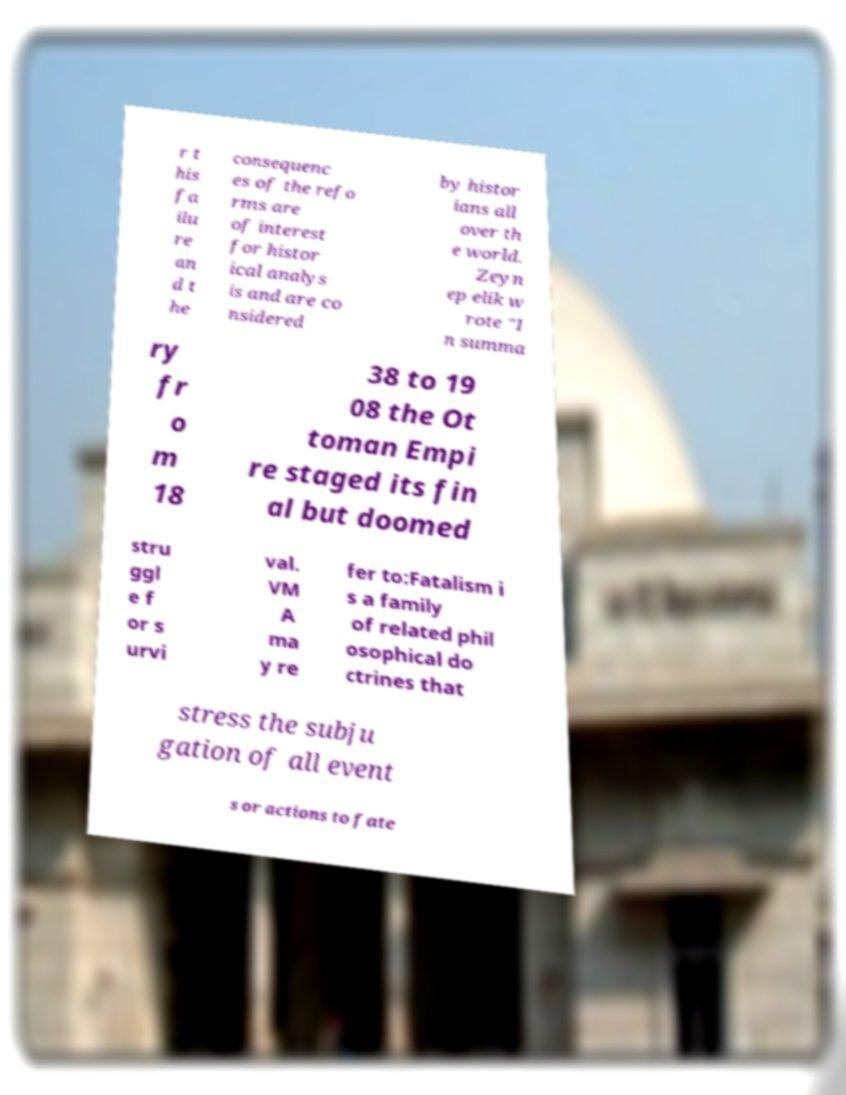For documentation purposes, I need the text within this image transcribed. Could you provide that? r t his fa ilu re an d t he consequenc es of the refo rms are of interest for histor ical analys is and are co nsidered by histor ians all over th e world. Zeyn ep elik w rote "I n summa ry fr o m 18 38 to 19 08 the Ot toman Empi re staged its fin al but doomed stru ggl e f or s urvi val. VM A ma y re fer to:Fatalism i s a family of related phil osophical do ctrines that stress the subju gation of all event s or actions to fate 